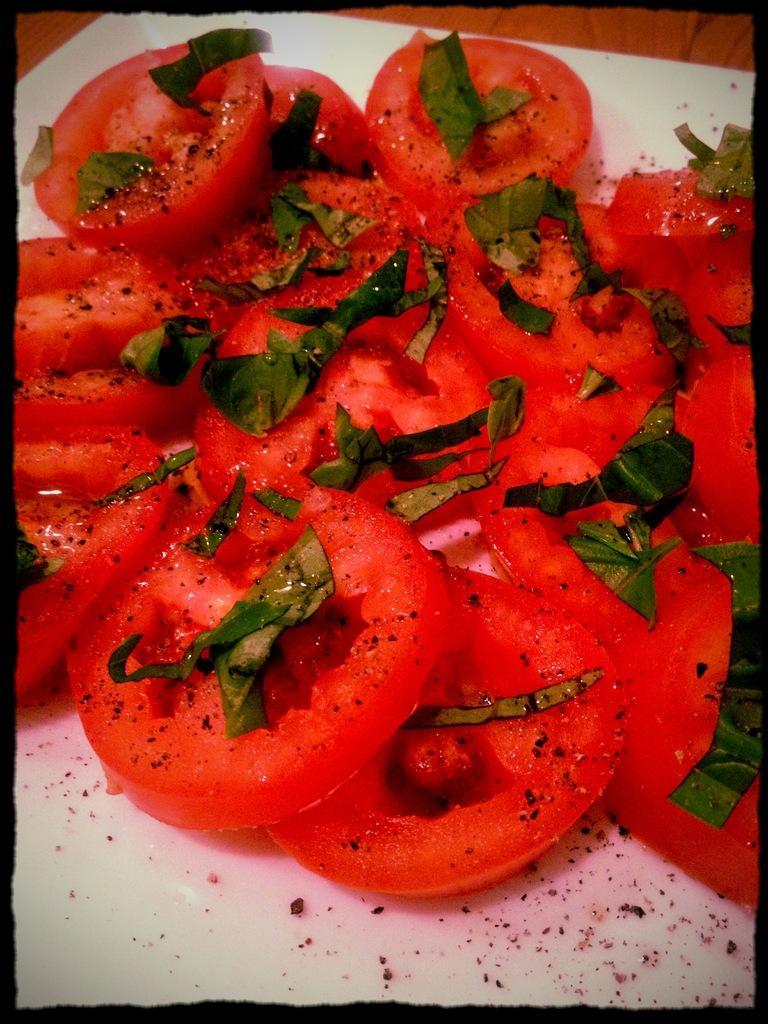Could you give a brief overview of what you see in this image? In this image there is the plate truncated towards the bottom of the image, there is food on the plate, the food is truncated. 